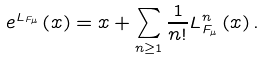Convert formula to latex. <formula><loc_0><loc_0><loc_500><loc_500>e ^ { L _ { F _ { \mu } } } \left ( x \right ) = x + \sum _ { n \geq 1 } \frac { 1 } { n ! } L ^ { n } _ { F _ { \mu } } \left ( x \right ) .</formula> 